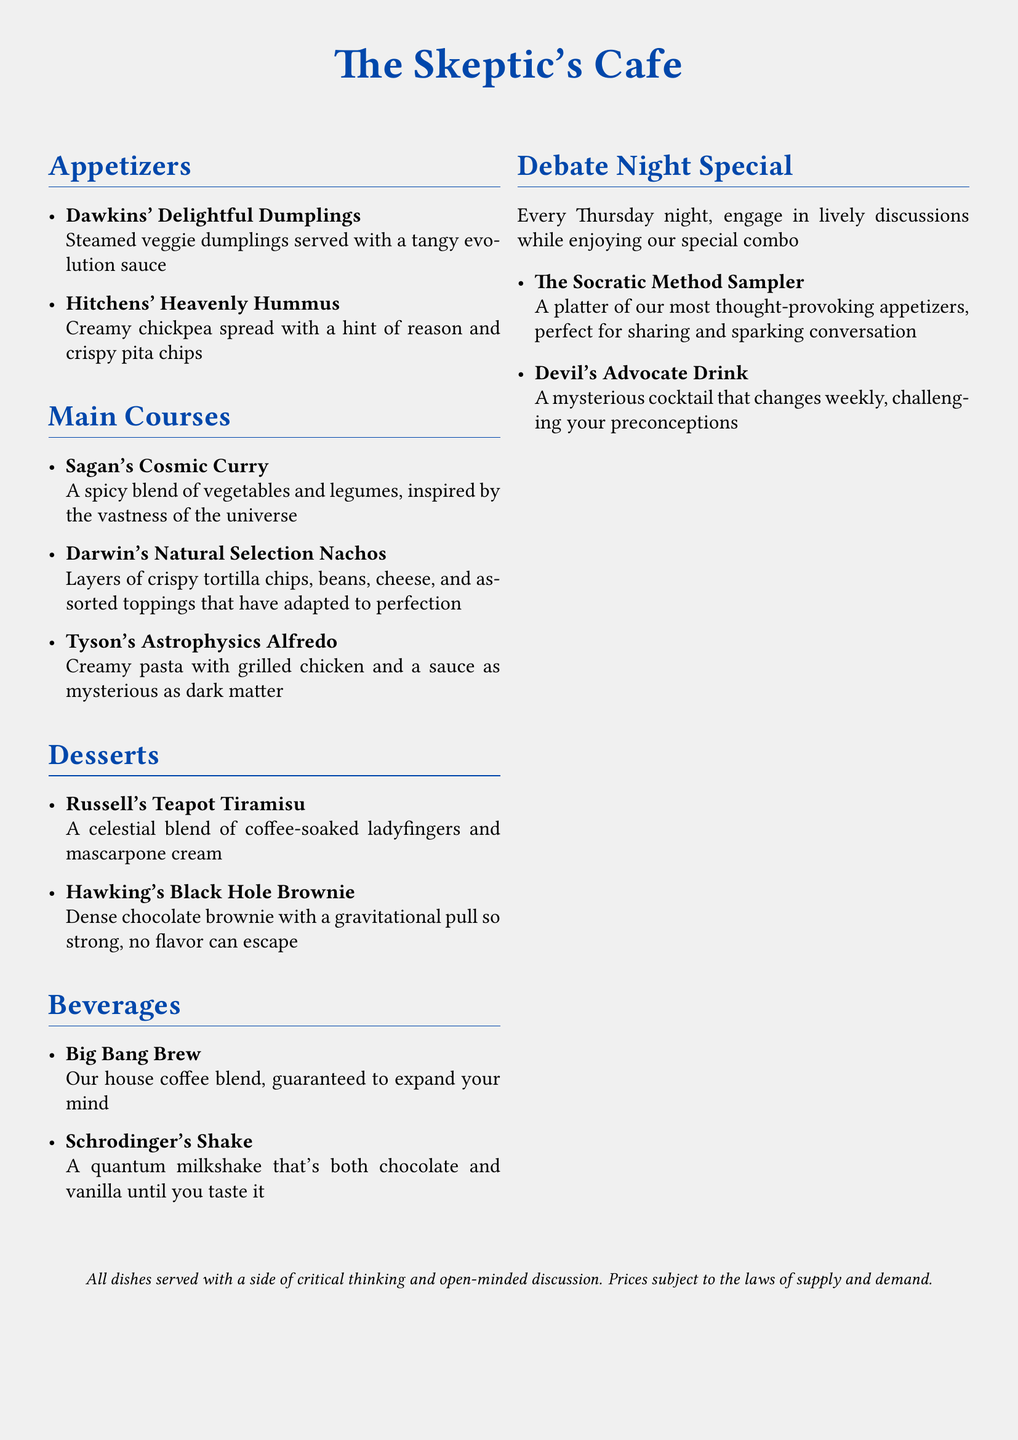What are the appetizers listed on the menu? The appetizers are specifically mentioned in the Appetizers section of the menu.
Answer: Dawkins' Delightful Dumplings, Hitchens' Heavenly Hummus How many main courses are there? The number of main courses can be found by counting the items listed in the Main Courses section.
Answer: Three What type of drink is featured in the Debate Night Special? The Debate Night Special includes a drink specifically named in that section of the menu.
Answer: Devil's Advocate Drink What dessert is named after a famous physicist? The desserts section includes items named after notable figures, including physicists.
Answer: Hawking's Black Hole Brownie What is the theme of the cafe menu? The theme can be inferred from the names of the dishes and their descriptions, reflecting on reason and skepticism.
Answer: Skepticism What day is the Debate Night Special available? The availability of the Debate Night Special is mentioned in the section's description.
Answer: Thursday Which dish features a 'tangy evolution sauce'? This detail is specified in the description of one of the appetizers.
Answer: Dawkins' Delightful Dumplings What type of curry is offered in the main courses? The type of curry is provided in the description of the main course listing.
Answer: Cosmic Curry 